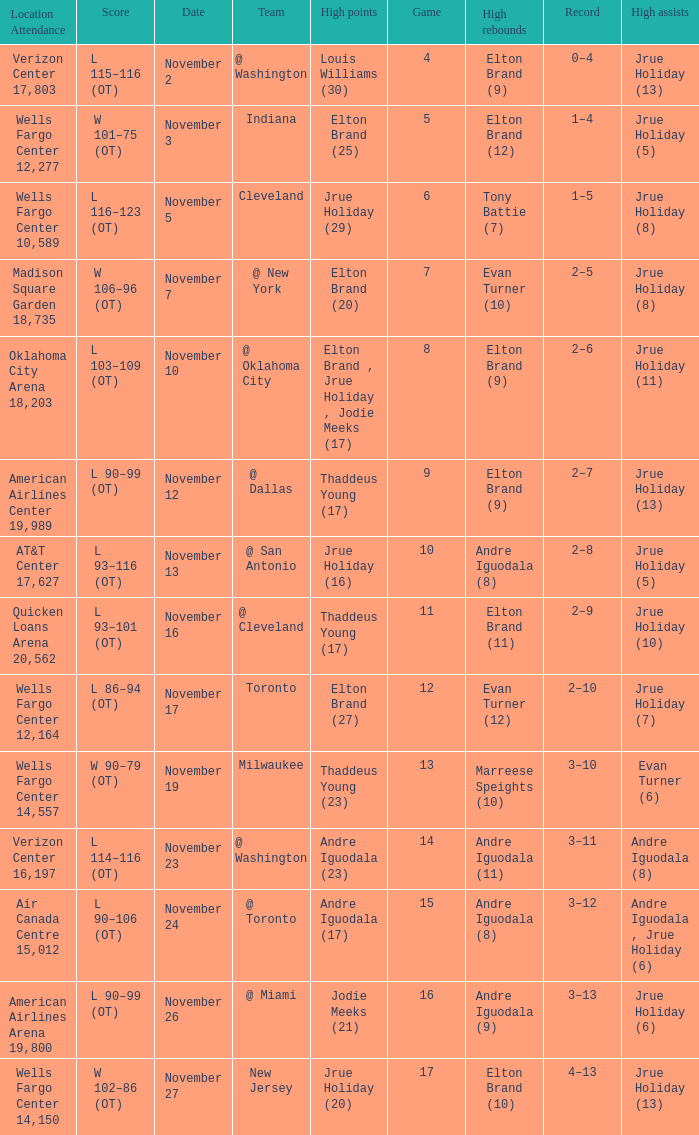What is the score for the game with the record of 3–12? L 90–106 (OT). 